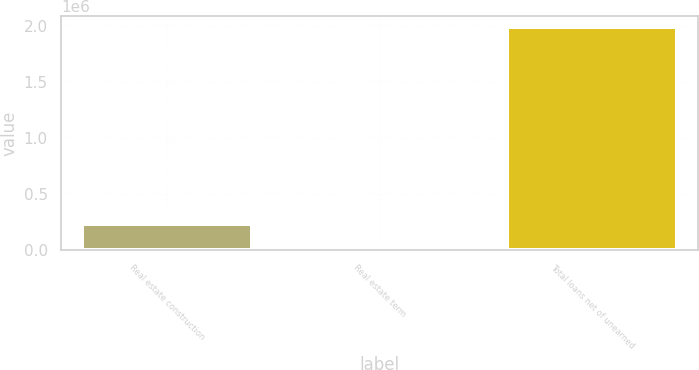Convert chart. <chart><loc_0><loc_0><loc_500><loc_500><bar_chart><fcel>Real estate construction<fcel>Real estate term<fcel>Total loans net of unearned<nl><fcel>227826<fcel>32115<fcel>1.98923e+06<nl></chart> 